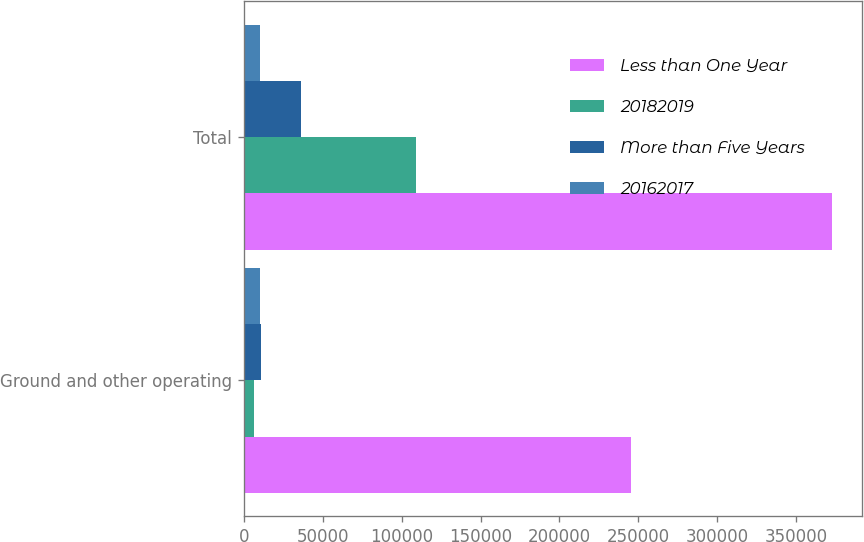Convert chart to OTSL. <chart><loc_0><loc_0><loc_500><loc_500><stacked_bar_chart><ecel><fcel>Ground and other operating<fcel>Total<nl><fcel>Less than One Year<fcel>245490<fcel>372759<nl><fcel>20182019<fcel>6756<fcel>109078<nl><fcel>More than Five Years<fcel>11208<fcel>36155<nl><fcel>20162017<fcel>10264<fcel>10264<nl></chart> 